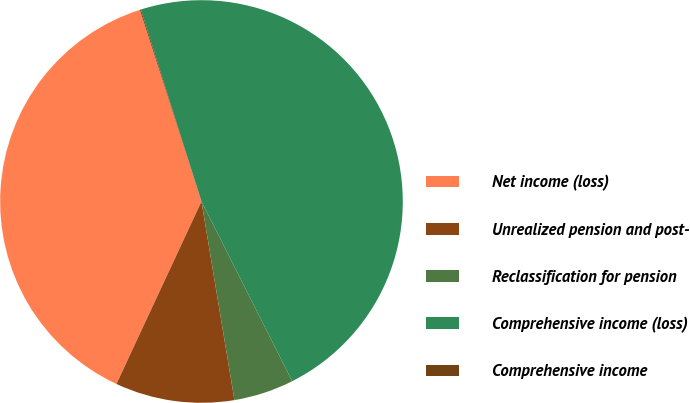Convert chart. <chart><loc_0><loc_0><loc_500><loc_500><pie_chart><fcel>Net income (loss)<fcel>Unrealized pension and post-<fcel>Reclassification for pension<fcel>Comprehensive income (loss)<fcel>Comprehensive income<nl><fcel>38.11%<fcel>9.56%<fcel>4.82%<fcel>47.43%<fcel>0.08%<nl></chart> 